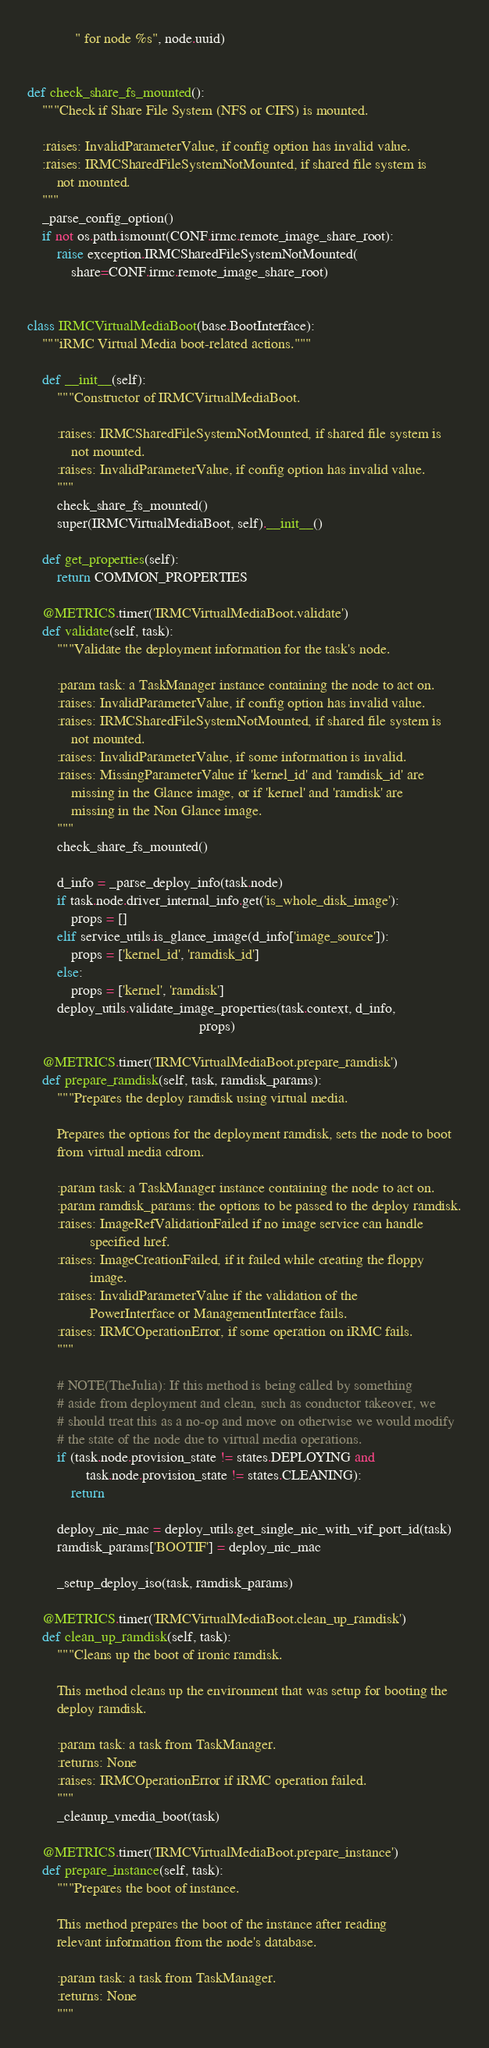Convert code to text. <code><loc_0><loc_0><loc_500><loc_500><_Python_>             " for node %s", node.uuid)


def check_share_fs_mounted():
    """Check if Share File System (NFS or CIFS) is mounted.

    :raises: InvalidParameterValue, if config option has invalid value.
    :raises: IRMCSharedFileSystemNotMounted, if shared file system is
        not mounted.
    """
    _parse_config_option()
    if not os.path.ismount(CONF.irmc.remote_image_share_root):
        raise exception.IRMCSharedFileSystemNotMounted(
            share=CONF.irmc.remote_image_share_root)


class IRMCVirtualMediaBoot(base.BootInterface):
    """iRMC Virtual Media boot-related actions."""

    def __init__(self):
        """Constructor of IRMCVirtualMediaBoot.

        :raises: IRMCSharedFileSystemNotMounted, if shared file system is
            not mounted.
        :raises: InvalidParameterValue, if config option has invalid value.
        """
        check_share_fs_mounted()
        super(IRMCVirtualMediaBoot, self).__init__()

    def get_properties(self):
        return COMMON_PROPERTIES

    @METRICS.timer('IRMCVirtualMediaBoot.validate')
    def validate(self, task):
        """Validate the deployment information for the task's node.

        :param task: a TaskManager instance containing the node to act on.
        :raises: InvalidParameterValue, if config option has invalid value.
        :raises: IRMCSharedFileSystemNotMounted, if shared file system is
            not mounted.
        :raises: InvalidParameterValue, if some information is invalid.
        :raises: MissingParameterValue if 'kernel_id' and 'ramdisk_id' are
            missing in the Glance image, or if 'kernel' and 'ramdisk' are
            missing in the Non Glance image.
        """
        check_share_fs_mounted()

        d_info = _parse_deploy_info(task.node)
        if task.node.driver_internal_info.get('is_whole_disk_image'):
            props = []
        elif service_utils.is_glance_image(d_info['image_source']):
            props = ['kernel_id', 'ramdisk_id']
        else:
            props = ['kernel', 'ramdisk']
        deploy_utils.validate_image_properties(task.context, d_info,
                                               props)

    @METRICS.timer('IRMCVirtualMediaBoot.prepare_ramdisk')
    def prepare_ramdisk(self, task, ramdisk_params):
        """Prepares the deploy ramdisk using virtual media.

        Prepares the options for the deployment ramdisk, sets the node to boot
        from virtual media cdrom.

        :param task: a TaskManager instance containing the node to act on.
        :param ramdisk_params: the options to be passed to the deploy ramdisk.
        :raises: ImageRefValidationFailed if no image service can handle
                 specified href.
        :raises: ImageCreationFailed, if it failed while creating the floppy
                 image.
        :raises: InvalidParameterValue if the validation of the
                 PowerInterface or ManagementInterface fails.
        :raises: IRMCOperationError, if some operation on iRMC fails.
        """

        # NOTE(TheJulia): If this method is being called by something
        # aside from deployment and clean, such as conductor takeover, we
        # should treat this as a no-op and move on otherwise we would modify
        # the state of the node due to virtual media operations.
        if (task.node.provision_state != states.DEPLOYING and
                task.node.provision_state != states.CLEANING):
            return

        deploy_nic_mac = deploy_utils.get_single_nic_with_vif_port_id(task)
        ramdisk_params['BOOTIF'] = deploy_nic_mac

        _setup_deploy_iso(task, ramdisk_params)

    @METRICS.timer('IRMCVirtualMediaBoot.clean_up_ramdisk')
    def clean_up_ramdisk(self, task):
        """Cleans up the boot of ironic ramdisk.

        This method cleans up the environment that was setup for booting the
        deploy ramdisk.

        :param task: a task from TaskManager.
        :returns: None
        :raises: IRMCOperationError if iRMC operation failed.
        """
        _cleanup_vmedia_boot(task)

    @METRICS.timer('IRMCVirtualMediaBoot.prepare_instance')
    def prepare_instance(self, task):
        """Prepares the boot of instance.

        This method prepares the boot of the instance after reading
        relevant information from the node's database.

        :param task: a task from TaskManager.
        :returns: None
        """</code> 